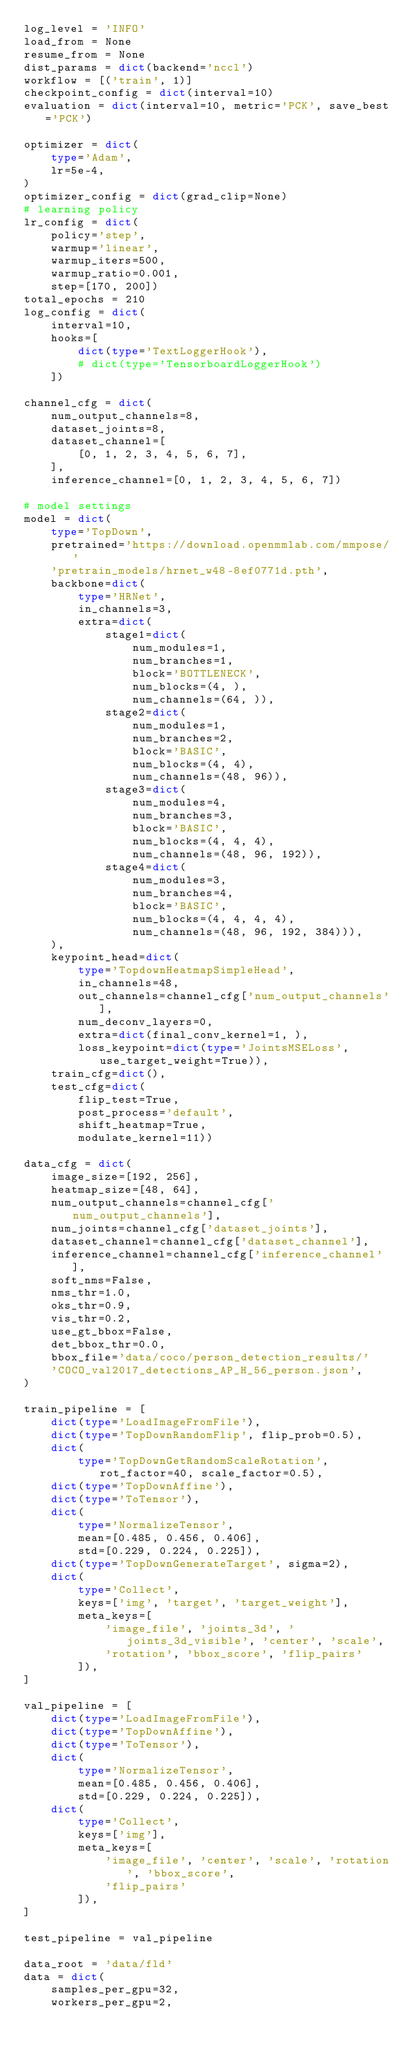Convert code to text. <code><loc_0><loc_0><loc_500><loc_500><_Python_>log_level = 'INFO'
load_from = None
resume_from = None
dist_params = dict(backend='nccl')
workflow = [('train', 1)]
checkpoint_config = dict(interval=10)
evaluation = dict(interval=10, metric='PCK', save_best='PCK')

optimizer = dict(
    type='Adam',
    lr=5e-4,
)
optimizer_config = dict(grad_clip=None)
# learning policy
lr_config = dict(
    policy='step',
    warmup='linear',
    warmup_iters=500,
    warmup_ratio=0.001,
    step=[170, 200])
total_epochs = 210
log_config = dict(
    interval=10,
    hooks=[
        dict(type='TextLoggerHook'),
        # dict(type='TensorboardLoggerHook')
    ])

channel_cfg = dict(
    num_output_channels=8,
    dataset_joints=8,
    dataset_channel=[
        [0, 1, 2, 3, 4, 5, 6, 7],
    ],
    inference_channel=[0, 1, 2, 3, 4, 5, 6, 7])

# model settings
model = dict(
    type='TopDown',
    pretrained='https://download.openmmlab.com/mmpose/'
    'pretrain_models/hrnet_w48-8ef0771d.pth',
    backbone=dict(
        type='HRNet',
        in_channels=3,
        extra=dict(
            stage1=dict(
                num_modules=1,
                num_branches=1,
                block='BOTTLENECK',
                num_blocks=(4, ),
                num_channels=(64, )),
            stage2=dict(
                num_modules=1,
                num_branches=2,
                block='BASIC',
                num_blocks=(4, 4),
                num_channels=(48, 96)),
            stage3=dict(
                num_modules=4,
                num_branches=3,
                block='BASIC',
                num_blocks=(4, 4, 4),
                num_channels=(48, 96, 192)),
            stage4=dict(
                num_modules=3,
                num_branches=4,
                block='BASIC',
                num_blocks=(4, 4, 4, 4),
                num_channels=(48, 96, 192, 384))),
    ),
    keypoint_head=dict(
        type='TopdownHeatmapSimpleHead',
        in_channels=48,
        out_channels=channel_cfg['num_output_channels'],
        num_deconv_layers=0,
        extra=dict(final_conv_kernel=1, ),
        loss_keypoint=dict(type='JointsMSELoss', use_target_weight=True)),
    train_cfg=dict(),
    test_cfg=dict(
        flip_test=True,
        post_process='default',
        shift_heatmap=True,
        modulate_kernel=11))

data_cfg = dict(
    image_size=[192, 256],
    heatmap_size=[48, 64],
    num_output_channels=channel_cfg['num_output_channels'],
    num_joints=channel_cfg['dataset_joints'],
    dataset_channel=channel_cfg['dataset_channel'],
    inference_channel=channel_cfg['inference_channel'],
    soft_nms=False,
    nms_thr=1.0,
    oks_thr=0.9,
    vis_thr=0.2,
    use_gt_bbox=False,
    det_bbox_thr=0.0,
    bbox_file='data/coco/person_detection_results/'
    'COCO_val2017_detections_AP_H_56_person.json',
)

train_pipeline = [
    dict(type='LoadImageFromFile'),
    dict(type='TopDownRandomFlip', flip_prob=0.5),
    dict(
        type='TopDownGetRandomScaleRotation', rot_factor=40, scale_factor=0.5),
    dict(type='TopDownAffine'),
    dict(type='ToTensor'),
    dict(
        type='NormalizeTensor',
        mean=[0.485, 0.456, 0.406],
        std=[0.229, 0.224, 0.225]),
    dict(type='TopDownGenerateTarget', sigma=2),
    dict(
        type='Collect',
        keys=['img', 'target', 'target_weight'],
        meta_keys=[
            'image_file', 'joints_3d', 'joints_3d_visible', 'center', 'scale',
            'rotation', 'bbox_score', 'flip_pairs'
        ]),
]

val_pipeline = [
    dict(type='LoadImageFromFile'),
    dict(type='TopDownAffine'),
    dict(type='ToTensor'),
    dict(
        type='NormalizeTensor',
        mean=[0.485, 0.456, 0.406],
        std=[0.229, 0.224, 0.225]),
    dict(
        type='Collect',
        keys=['img'],
        meta_keys=[
            'image_file', 'center', 'scale', 'rotation', 'bbox_score',
            'flip_pairs'
        ]),
]

test_pipeline = val_pipeline

data_root = 'data/fld'
data = dict(
    samples_per_gpu=32,
    workers_per_gpu=2,</code> 